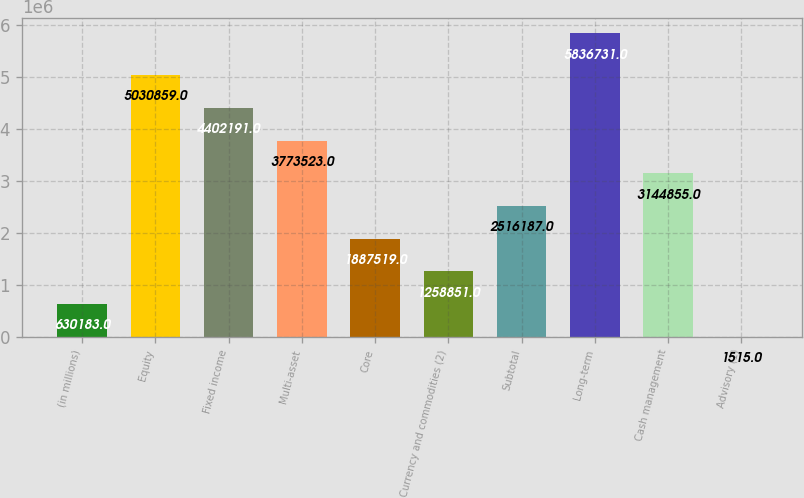Convert chart to OTSL. <chart><loc_0><loc_0><loc_500><loc_500><bar_chart><fcel>(in millions)<fcel>Equity<fcel>Fixed income<fcel>Multi-asset<fcel>Core<fcel>Currency and commodities (2)<fcel>Subtotal<fcel>Long-term<fcel>Cash management<fcel>Advisory (1)<nl><fcel>630183<fcel>5.03086e+06<fcel>4.40219e+06<fcel>3.77352e+06<fcel>1.88752e+06<fcel>1.25885e+06<fcel>2.51619e+06<fcel>5.83673e+06<fcel>3.14486e+06<fcel>1515<nl></chart> 